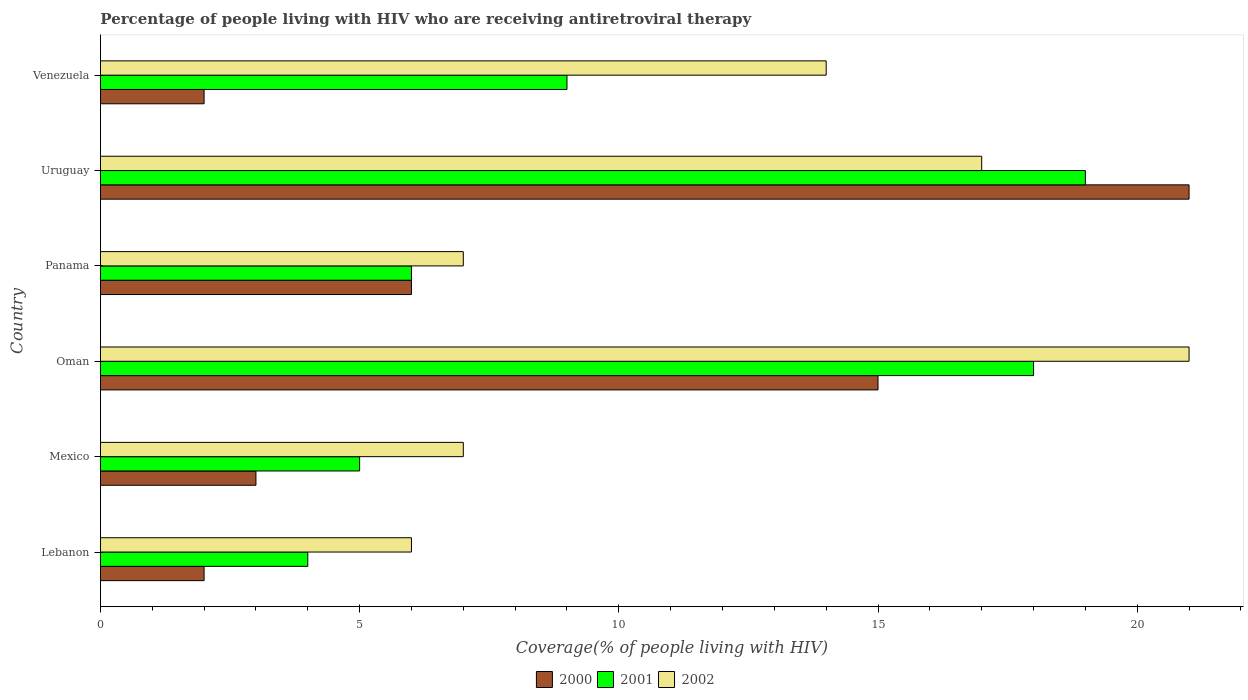Are the number of bars per tick equal to the number of legend labels?
Your response must be concise. Yes. Are the number of bars on each tick of the Y-axis equal?
Give a very brief answer. Yes. How many bars are there on the 3rd tick from the top?
Make the answer very short. 3. What is the label of the 3rd group of bars from the top?
Provide a succinct answer. Panama. In how many cases, is the number of bars for a given country not equal to the number of legend labels?
Your response must be concise. 0. Across all countries, what is the maximum percentage of the HIV infected people who are receiving antiretroviral therapy in 2001?
Your response must be concise. 19. Across all countries, what is the minimum percentage of the HIV infected people who are receiving antiretroviral therapy in 2000?
Ensure brevity in your answer.  2. In which country was the percentage of the HIV infected people who are receiving antiretroviral therapy in 2002 maximum?
Offer a very short reply. Oman. In which country was the percentage of the HIV infected people who are receiving antiretroviral therapy in 2000 minimum?
Ensure brevity in your answer.  Lebanon. What is the total percentage of the HIV infected people who are receiving antiretroviral therapy in 2001 in the graph?
Offer a terse response. 61. What is the difference between the percentage of the HIV infected people who are receiving antiretroviral therapy in 2000 in Mexico and that in Oman?
Offer a very short reply. -12. What is the difference between the percentage of the HIV infected people who are receiving antiretroviral therapy in 2002 in Panama and the percentage of the HIV infected people who are receiving antiretroviral therapy in 2000 in Uruguay?
Give a very brief answer. -14. What is the average percentage of the HIV infected people who are receiving antiretroviral therapy in 2001 per country?
Give a very brief answer. 10.17. What is the ratio of the percentage of the HIV infected people who are receiving antiretroviral therapy in 2000 in Lebanon to that in Venezuela?
Offer a terse response. 1. Is the percentage of the HIV infected people who are receiving antiretroviral therapy in 2002 in Lebanon less than that in Venezuela?
Offer a terse response. Yes. Is the difference between the percentage of the HIV infected people who are receiving antiretroviral therapy in 2000 in Oman and Uruguay greater than the difference between the percentage of the HIV infected people who are receiving antiretroviral therapy in 2002 in Oman and Uruguay?
Your answer should be very brief. No. Is the sum of the percentage of the HIV infected people who are receiving antiretroviral therapy in 2000 in Mexico and Venezuela greater than the maximum percentage of the HIV infected people who are receiving antiretroviral therapy in 2001 across all countries?
Provide a succinct answer. No. What does the 2nd bar from the top in Venezuela represents?
Provide a short and direct response. 2001. Is it the case that in every country, the sum of the percentage of the HIV infected people who are receiving antiretroviral therapy in 2001 and percentage of the HIV infected people who are receiving antiretroviral therapy in 2002 is greater than the percentage of the HIV infected people who are receiving antiretroviral therapy in 2000?
Offer a terse response. Yes. How many bars are there?
Provide a succinct answer. 18. How many legend labels are there?
Ensure brevity in your answer.  3. What is the title of the graph?
Give a very brief answer. Percentage of people living with HIV who are receiving antiretroviral therapy. Does "1965" appear as one of the legend labels in the graph?
Provide a short and direct response. No. What is the label or title of the X-axis?
Offer a very short reply. Coverage(% of people living with HIV). What is the Coverage(% of people living with HIV) of 2000 in Oman?
Your answer should be compact. 15. What is the Coverage(% of people living with HIV) in 2002 in Oman?
Provide a succinct answer. 21. What is the Coverage(% of people living with HIV) in 2000 in Panama?
Provide a short and direct response. 6. What is the Coverage(% of people living with HIV) in 2000 in Uruguay?
Your answer should be compact. 21. What is the Coverage(% of people living with HIV) of 2001 in Uruguay?
Provide a short and direct response. 19. What is the Coverage(% of people living with HIV) of 2002 in Uruguay?
Ensure brevity in your answer.  17. Across all countries, what is the maximum Coverage(% of people living with HIV) of 2000?
Keep it short and to the point. 21. Across all countries, what is the maximum Coverage(% of people living with HIV) in 2001?
Your response must be concise. 19. Across all countries, what is the maximum Coverage(% of people living with HIV) of 2002?
Your answer should be very brief. 21. Across all countries, what is the minimum Coverage(% of people living with HIV) of 2000?
Provide a succinct answer. 2. What is the total Coverage(% of people living with HIV) of 2000 in the graph?
Provide a short and direct response. 49. What is the total Coverage(% of people living with HIV) in 2001 in the graph?
Provide a succinct answer. 61. What is the total Coverage(% of people living with HIV) in 2002 in the graph?
Provide a short and direct response. 72. What is the difference between the Coverage(% of people living with HIV) of 2000 in Lebanon and that in Mexico?
Keep it short and to the point. -1. What is the difference between the Coverage(% of people living with HIV) of 2001 in Lebanon and that in Mexico?
Offer a terse response. -1. What is the difference between the Coverage(% of people living with HIV) in 2001 in Lebanon and that in Oman?
Your answer should be very brief. -14. What is the difference between the Coverage(% of people living with HIV) of 2002 in Lebanon and that in Panama?
Give a very brief answer. -1. What is the difference between the Coverage(% of people living with HIV) in 2000 in Lebanon and that in Uruguay?
Your answer should be very brief. -19. What is the difference between the Coverage(% of people living with HIV) of 2002 in Lebanon and that in Uruguay?
Offer a terse response. -11. What is the difference between the Coverage(% of people living with HIV) in 2000 in Lebanon and that in Venezuela?
Offer a terse response. 0. What is the difference between the Coverage(% of people living with HIV) of 2001 in Lebanon and that in Venezuela?
Your answer should be compact. -5. What is the difference between the Coverage(% of people living with HIV) in 2002 in Lebanon and that in Venezuela?
Keep it short and to the point. -8. What is the difference between the Coverage(% of people living with HIV) in 2000 in Mexico and that in Oman?
Offer a terse response. -12. What is the difference between the Coverage(% of people living with HIV) of 2002 in Mexico and that in Oman?
Your response must be concise. -14. What is the difference between the Coverage(% of people living with HIV) in 2001 in Mexico and that in Panama?
Your answer should be compact. -1. What is the difference between the Coverage(% of people living with HIV) of 2001 in Mexico and that in Uruguay?
Your answer should be compact. -14. What is the difference between the Coverage(% of people living with HIV) in 2002 in Mexico and that in Uruguay?
Your answer should be compact. -10. What is the difference between the Coverage(% of people living with HIV) of 2001 in Oman and that in Panama?
Offer a terse response. 12. What is the difference between the Coverage(% of people living with HIV) of 2002 in Oman and that in Panama?
Make the answer very short. 14. What is the difference between the Coverage(% of people living with HIV) in 2001 in Oman and that in Uruguay?
Ensure brevity in your answer.  -1. What is the difference between the Coverage(% of people living with HIV) of 2000 in Oman and that in Venezuela?
Ensure brevity in your answer.  13. What is the difference between the Coverage(% of people living with HIV) in 2001 in Oman and that in Venezuela?
Give a very brief answer. 9. What is the difference between the Coverage(% of people living with HIV) in 2000 in Uruguay and that in Venezuela?
Your answer should be very brief. 19. What is the difference between the Coverage(% of people living with HIV) in 2001 in Uruguay and that in Venezuela?
Offer a very short reply. 10. What is the difference between the Coverage(% of people living with HIV) of 2002 in Uruguay and that in Venezuela?
Offer a terse response. 3. What is the difference between the Coverage(% of people living with HIV) in 2000 in Lebanon and the Coverage(% of people living with HIV) in 2001 in Mexico?
Keep it short and to the point. -3. What is the difference between the Coverage(% of people living with HIV) of 2001 in Lebanon and the Coverage(% of people living with HIV) of 2002 in Mexico?
Keep it short and to the point. -3. What is the difference between the Coverage(% of people living with HIV) in 2000 in Lebanon and the Coverage(% of people living with HIV) in 2001 in Oman?
Your answer should be compact. -16. What is the difference between the Coverage(% of people living with HIV) in 2000 in Lebanon and the Coverage(% of people living with HIV) in 2002 in Oman?
Offer a very short reply. -19. What is the difference between the Coverage(% of people living with HIV) of 2000 in Lebanon and the Coverage(% of people living with HIV) of 2001 in Uruguay?
Offer a very short reply. -17. What is the difference between the Coverage(% of people living with HIV) of 2000 in Lebanon and the Coverage(% of people living with HIV) of 2002 in Uruguay?
Give a very brief answer. -15. What is the difference between the Coverage(% of people living with HIV) in 2001 in Lebanon and the Coverage(% of people living with HIV) in 2002 in Uruguay?
Your answer should be very brief. -13. What is the difference between the Coverage(% of people living with HIV) in 2001 in Lebanon and the Coverage(% of people living with HIV) in 2002 in Venezuela?
Your answer should be very brief. -10. What is the difference between the Coverage(% of people living with HIV) in 2000 in Mexico and the Coverage(% of people living with HIV) in 2001 in Oman?
Give a very brief answer. -15. What is the difference between the Coverage(% of people living with HIV) of 2000 in Mexico and the Coverage(% of people living with HIV) of 2002 in Oman?
Keep it short and to the point. -18. What is the difference between the Coverage(% of people living with HIV) of 2001 in Mexico and the Coverage(% of people living with HIV) of 2002 in Oman?
Make the answer very short. -16. What is the difference between the Coverage(% of people living with HIV) in 2000 in Mexico and the Coverage(% of people living with HIV) in 2001 in Panama?
Provide a short and direct response. -3. What is the difference between the Coverage(% of people living with HIV) in 2001 in Mexico and the Coverage(% of people living with HIV) in 2002 in Panama?
Offer a terse response. -2. What is the difference between the Coverage(% of people living with HIV) in 2000 in Mexico and the Coverage(% of people living with HIV) in 2001 in Uruguay?
Give a very brief answer. -16. What is the difference between the Coverage(% of people living with HIV) in 2000 in Mexico and the Coverage(% of people living with HIV) in 2001 in Venezuela?
Your response must be concise. -6. What is the difference between the Coverage(% of people living with HIV) of 2000 in Mexico and the Coverage(% of people living with HIV) of 2002 in Venezuela?
Ensure brevity in your answer.  -11. What is the difference between the Coverage(% of people living with HIV) in 2000 in Oman and the Coverage(% of people living with HIV) in 2001 in Panama?
Provide a succinct answer. 9. What is the difference between the Coverage(% of people living with HIV) of 2000 in Oman and the Coverage(% of people living with HIV) of 2002 in Panama?
Make the answer very short. 8. What is the difference between the Coverage(% of people living with HIV) in 2000 in Oman and the Coverage(% of people living with HIV) in 2002 in Uruguay?
Provide a short and direct response. -2. What is the difference between the Coverage(% of people living with HIV) of 2000 in Oman and the Coverage(% of people living with HIV) of 2001 in Venezuela?
Give a very brief answer. 6. What is the difference between the Coverage(% of people living with HIV) in 2001 in Oman and the Coverage(% of people living with HIV) in 2002 in Venezuela?
Offer a terse response. 4. What is the difference between the Coverage(% of people living with HIV) in 2000 in Panama and the Coverage(% of people living with HIV) in 2001 in Uruguay?
Offer a very short reply. -13. What is the difference between the Coverage(% of people living with HIV) in 2001 in Panama and the Coverage(% of people living with HIV) in 2002 in Uruguay?
Offer a very short reply. -11. What is the difference between the Coverage(% of people living with HIV) of 2001 in Panama and the Coverage(% of people living with HIV) of 2002 in Venezuela?
Offer a very short reply. -8. What is the difference between the Coverage(% of people living with HIV) of 2000 in Uruguay and the Coverage(% of people living with HIV) of 2001 in Venezuela?
Provide a succinct answer. 12. What is the average Coverage(% of people living with HIV) in 2000 per country?
Provide a succinct answer. 8.17. What is the average Coverage(% of people living with HIV) of 2001 per country?
Your answer should be very brief. 10.17. What is the average Coverage(% of people living with HIV) of 2002 per country?
Provide a succinct answer. 12. What is the difference between the Coverage(% of people living with HIV) of 2000 and Coverage(% of people living with HIV) of 2001 in Lebanon?
Your response must be concise. -2. What is the difference between the Coverage(% of people living with HIV) of 2000 and Coverage(% of people living with HIV) of 2002 in Lebanon?
Ensure brevity in your answer.  -4. What is the difference between the Coverage(% of people living with HIV) in 2001 and Coverage(% of people living with HIV) in 2002 in Lebanon?
Ensure brevity in your answer.  -2. What is the difference between the Coverage(% of people living with HIV) in 2001 and Coverage(% of people living with HIV) in 2002 in Mexico?
Make the answer very short. -2. What is the difference between the Coverage(% of people living with HIV) of 2000 and Coverage(% of people living with HIV) of 2001 in Oman?
Your answer should be very brief. -3. What is the difference between the Coverage(% of people living with HIV) in 2000 and Coverage(% of people living with HIV) in 2002 in Oman?
Your response must be concise. -6. What is the difference between the Coverage(% of people living with HIV) in 2001 and Coverage(% of people living with HIV) in 2002 in Oman?
Your answer should be compact. -3. What is the difference between the Coverage(% of people living with HIV) of 2000 and Coverage(% of people living with HIV) of 2001 in Panama?
Make the answer very short. 0. What is the difference between the Coverage(% of people living with HIV) in 2001 and Coverage(% of people living with HIV) in 2002 in Uruguay?
Your answer should be compact. 2. What is the ratio of the Coverage(% of people living with HIV) in 2000 in Lebanon to that in Mexico?
Keep it short and to the point. 0.67. What is the ratio of the Coverage(% of people living with HIV) of 2001 in Lebanon to that in Mexico?
Give a very brief answer. 0.8. What is the ratio of the Coverage(% of people living with HIV) of 2000 in Lebanon to that in Oman?
Offer a very short reply. 0.13. What is the ratio of the Coverage(% of people living with HIV) in 2001 in Lebanon to that in Oman?
Ensure brevity in your answer.  0.22. What is the ratio of the Coverage(% of people living with HIV) of 2002 in Lebanon to that in Oman?
Keep it short and to the point. 0.29. What is the ratio of the Coverage(% of people living with HIV) of 2001 in Lebanon to that in Panama?
Keep it short and to the point. 0.67. What is the ratio of the Coverage(% of people living with HIV) of 2000 in Lebanon to that in Uruguay?
Your response must be concise. 0.1. What is the ratio of the Coverage(% of people living with HIV) in 2001 in Lebanon to that in Uruguay?
Provide a succinct answer. 0.21. What is the ratio of the Coverage(% of people living with HIV) in 2002 in Lebanon to that in Uruguay?
Make the answer very short. 0.35. What is the ratio of the Coverage(% of people living with HIV) in 2001 in Lebanon to that in Venezuela?
Offer a terse response. 0.44. What is the ratio of the Coverage(% of people living with HIV) in 2002 in Lebanon to that in Venezuela?
Keep it short and to the point. 0.43. What is the ratio of the Coverage(% of people living with HIV) of 2000 in Mexico to that in Oman?
Provide a short and direct response. 0.2. What is the ratio of the Coverage(% of people living with HIV) of 2001 in Mexico to that in Oman?
Your answer should be very brief. 0.28. What is the ratio of the Coverage(% of people living with HIV) of 2001 in Mexico to that in Panama?
Your answer should be compact. 0.83. What is the ratio of the Coverage(% of people living with HIV) of 2000 in Mexico to that in Uruguay?
Provide a short and direct response. 0.14. What is the ratio of the Coverage(% of people living with HIV) in 2001 in Mexico to that in Uruguay?
Your answer should be compact. 0.26. What is the ratio of the Coverage(% of people living with HIV) in 2002 in Mexico to that in Uruguay?
Offer a very short reply. 0.41. What is the ratio of the Coverage(% of people living with HIV) of 2001 in Mexico to that in Venezuela?
Make the answer very short. 0.56. What is the ratio of the Coverage(% of people living with HIV) in 2002 in Oman to that in Panama?
Provide a short and direct response. 3. What is the ratio of the Coverage(% of people living with HIV) of 2000 in Oman to that in Uruguay?
Make the answer very short. 0.71. What is the ratio of the Coverage(% of people living with HIV) in 2002 in Oman to that in Uruguay?
Ensure brevity in your answer.  1.24. What is the ratio of the Coverage(% of people living with HIV) of 2000 in Oman to that in Venezuela?
Provide a short and direct response. 7.5. What is the ratio of the Coverage(% of people living with HIV) in 2002 in Oman to that in Venezuela?
Your response must be concise. 1.5. What is the ratio of the Coverage(% of people living with HIV) of 2000 in Panama to that in Uruguay?
Ensure brevity in your answer.  0.29. What is the ratio of the Coverage(% of people living with HIV) of 2001 in Panama to that in Uruguay?
Keep it short and to the point. 0.32. What is the ratio of the Coverage(% of people living with HIV) in 2002 in Panama to that in Uruguay?
Offer a very short reply. 0.41. What is the ratio of the Coverage(% of people living with HIV) of 2000 in Panama to that in Venezuela?
Provide a short and direct response. 3. What is the ratio of the Coverage(% of people living with HIV) in 2001 in Panama to that in Venezuela?
Keep it short and to the point. 0.67. What is the ratio of the Coverage(% of people living with HIV) of 2002 in Panama to that in Venezuela?
Keep it short and to the point. 0.5. What is the ratio of the Coverage(% of people living with HIV) in 2001 in Uruguay to that in Venezuela?
Give a very brief answer. 2.11. What is the ratio of the Coverage(% of people living with HIV) in 2002 in Uruguay to that in Venezuela?
Provide a succinct answer. 1.21. What is the difference between the highest and the second highest Coverage(% of people living with HIV) in 2000?
Make the answer very short. 6. What is the difference between the highest and the lowest Coverage(% of people living with HIV) in 2001?
Your response must be concise. 15. What is the difference between the highest and the lowest Coverage(% of people living with HIV) of 2002?
Offer a very short reply. 15. 